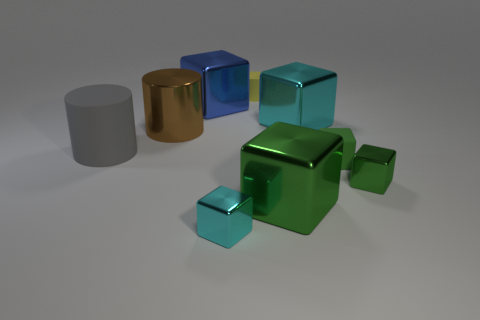There is a matte object that is behind the large brown metallic cylinder; does it have the same size as the cyan cube behind the large rubber cylinder?
Make the answer very short. No. What number of objects have the same material as the big gray cylinder?
Provide a succinct answer. 2. How many small blocks are left of the tiny shiny thing that is on the right side of the matte cylinder that is right of the tiny cyan block?
Ensure brevity in your answer.  2. Is the shape of the tiny green matte object the same as the big gray thing?
Keep it short and to the point. No. Is there a yellow object that has the same shape as the green matte object?
Your response must be concise. No. There is a matte object that is the same size as the green rubber cube; what shape is it?
Provide a succinct answer. Cylinder. There is a big cube that is left of the tiny metal block on the left side of the small yellow rubber cylinder on the left side of the large green metal cube; what is it made of?
Provide a short and direct response. Metal. Do the gray rubber thing and the rubber cube have the same size?
Give a very brief answer. No. What is the material of the gray object?
Give a very brief answer. Rubber. There is a small thing that is the same color as the small rubber block; what is it made of?
Give a very brief answer. Metal. 